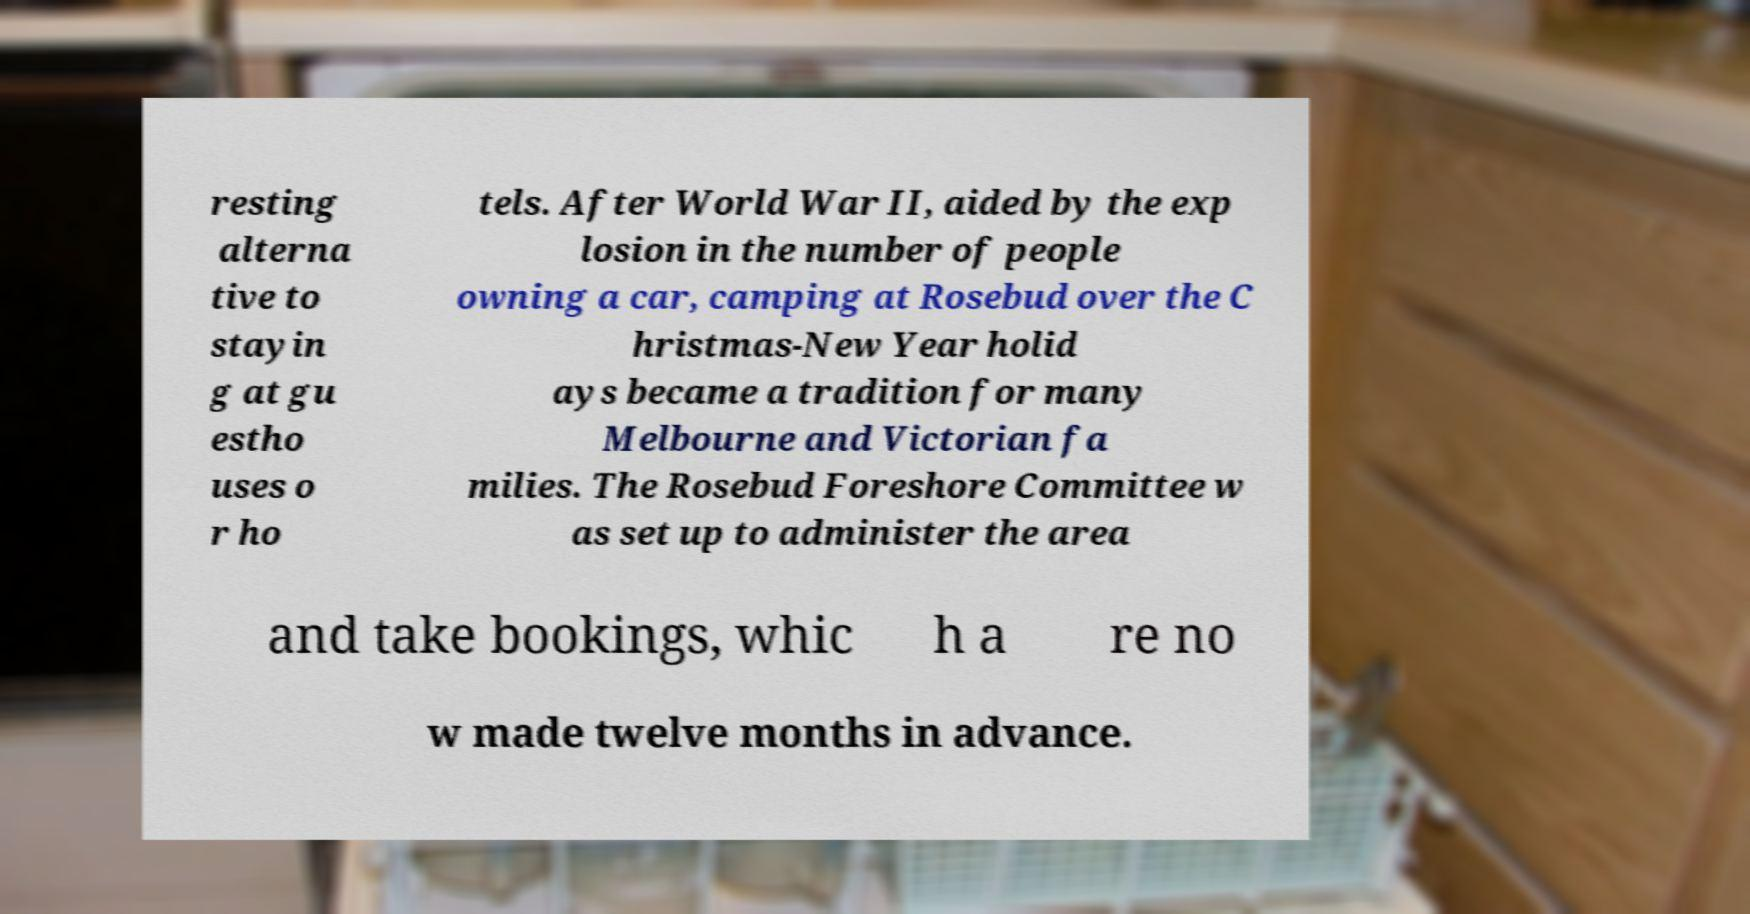Can you read and provide the text displayed in the image?This photo seems to have some interesting text. Can you extract and type it out for me? resting alterna tive to stayin g at gu estho uses o r ho tels. After World War II, aided by the exp losion in the number of people owning a car, camping at Rosebud over the C hristmas-New Year holid ays became a tradition for many Melbourne and Victorian fa milies. The Rosebud Foreshore Committee w as set up to administer the area and take bookings, whic h a re no w made twelve months in advance. 